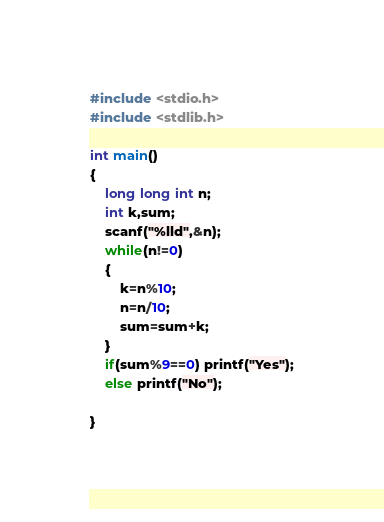Convert code to text. <code><loc_0><loc_0><loc_500><loc_500><_C_>#include <stdio.h>
#include <stdlib.h>

int main()
{
    long long int n;
    int k,sum;
    scanf("%lld",&n);
    while(n!=0)
    {
        k=n%10;
        n=n/10;
        sum=sum+k;
    }
    if(sum%9==0) printf("Yes");
    else printf("No");

}
</code> 